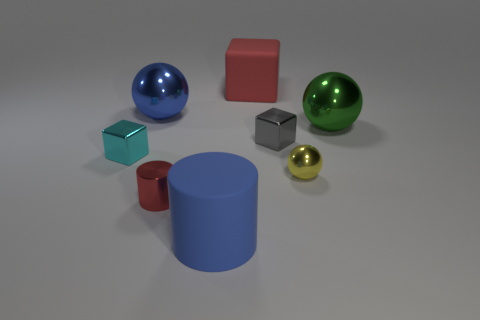Add 1 tiny blue rubber objects. How many objects exist? 9 Subtract all balls. How many objects are left? 5 Add 2 blue metal spheres. How many blue metal spheres exist? 3 Subtract 0 purple spheres. How many objects are left? 8 Subtract all blue shiny balls. Subtract all green matte cylinders. How many objects are left? 7 Add 6 cyan objects. How many cyan objects are left? 7 